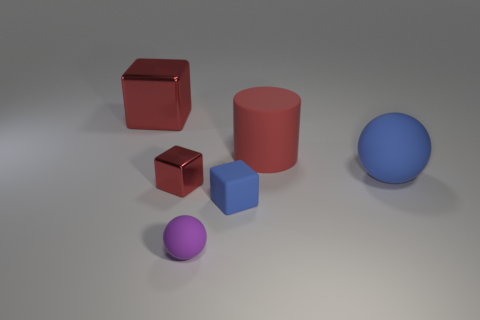Do the blue thing that is on the left side of the large blue thing and the small red shiny thing have the same shape?
Give a very brief answer. Yes. There is a big matte thing that is the same color as the large cube; what shape is it?
Offer a terse response. Cylinder. The rubber cylinder that is the same color as the large metal cube is what size?
Keep it short and to the point. Large. Do the tiny metallic thing and the small blue rubber object have the same shape?
Make the answer very short. Yes. What number of other things are the same shape as the large blue thing?
Provide a succinct answer. 1. There is a ball that is to the left of the big red cylinder; is its size the same as the metallic thing behind the small red block?
Your response must be concise. No. How many cylinders are either small blue objects or matte things?
Your response must be concise. 1. How many metallic objects are blue things or large purple blocks?
Provide a succinct answer. 0. What size is the blue object that is the same shape as the tiny red thing?
Give a very brief answer. Small. There is a cylinder; is its size the same as the matte ball in front of the rubber cube?
Provide a succinct answer. No. 